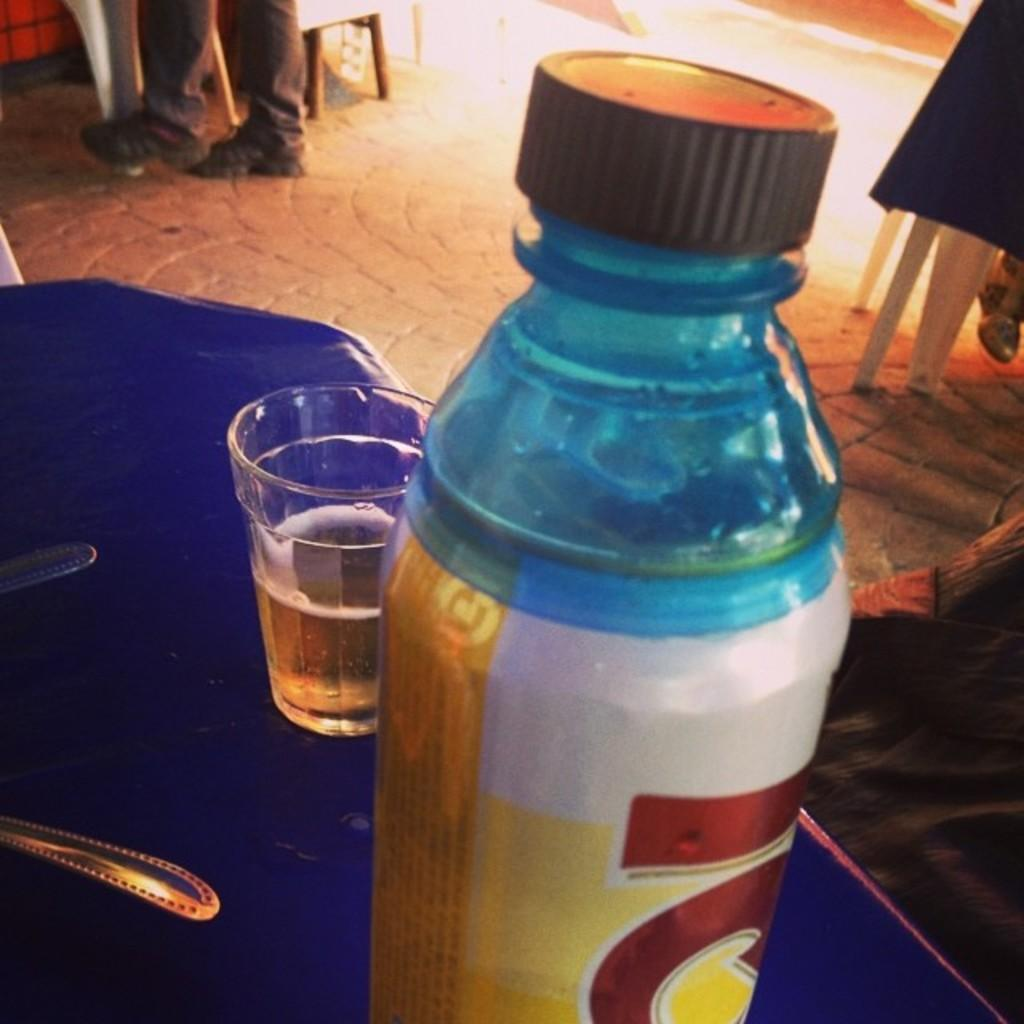What is on the table in the image? There is a bottle and a glass with some drink on the table. What utensil can be seen in the image? There is a spoon visible in the image. Can you describe anything in the background of the image? Human legs are present in the background of the image. What type of gold nail can be seen in the image? There is no gold nail present in the image. 